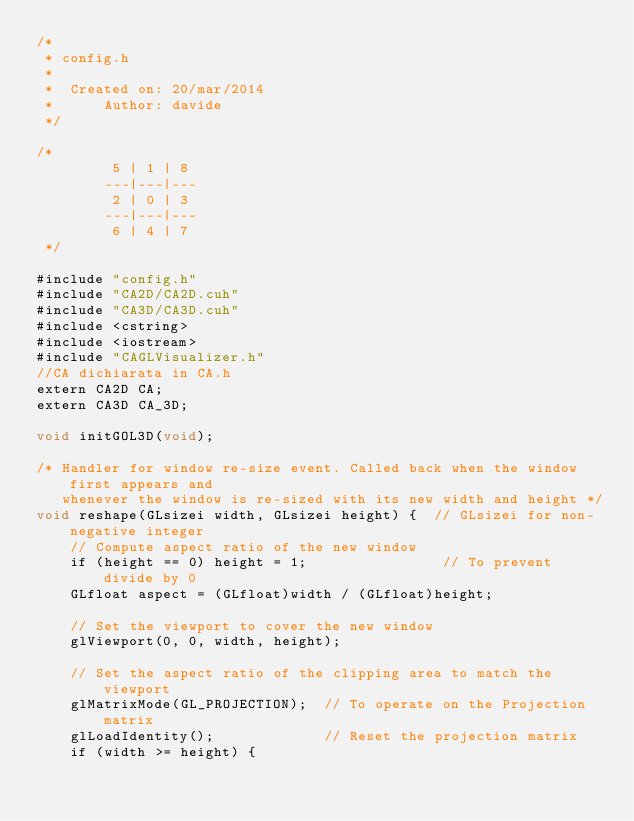Convert code to text. <code><loc_0><loc_0><loc_500><loc_500><_Cuda_>/*
 * config.h
 *
 *  Created on: 20/mar/2014
 *      Author: davide
 */

/*
         5 | 1 | 8
        ---|---|---
         2 | 0 | 3
        ---|---|---
         6 | 4 | 7
 */

#include "config.h"
#include "CA2D/CA2D.cuh"
#include "CA3D/CA3D.cuh"
#include <cstring>
#include <iostream>
#include "CAGLVisualizer.h"
//CA dichiarata in CA.h
extern CA2D CA;
extern CA3D CA_3D;

void initGOL3D(void);

/* Handler for window re-size event. Called back when the window first appears and
   whenever the window is re-sized with its new width and height */
void reshape(GLsizei width, GLsizei height) {  // GLsizei for non-negative integer
	// Compute aspect ratio of the new window
	if (height == 0) height = 1;                // To prevent divide by 0
	GLfloat aspect = (GLfloat)width / (GLfloat)height;

	// Set the viewport to cover the new window
	glViewport(0, 0, width, height);

	// Set the aspect ratio of the clipping area to match the viewport
	glMatrixMode(GL_PROJECTION);  // To operate on the Projection matrix
	glLoadIdentity();             // Reset the projection matrix
	if (width >= height) {</code> 